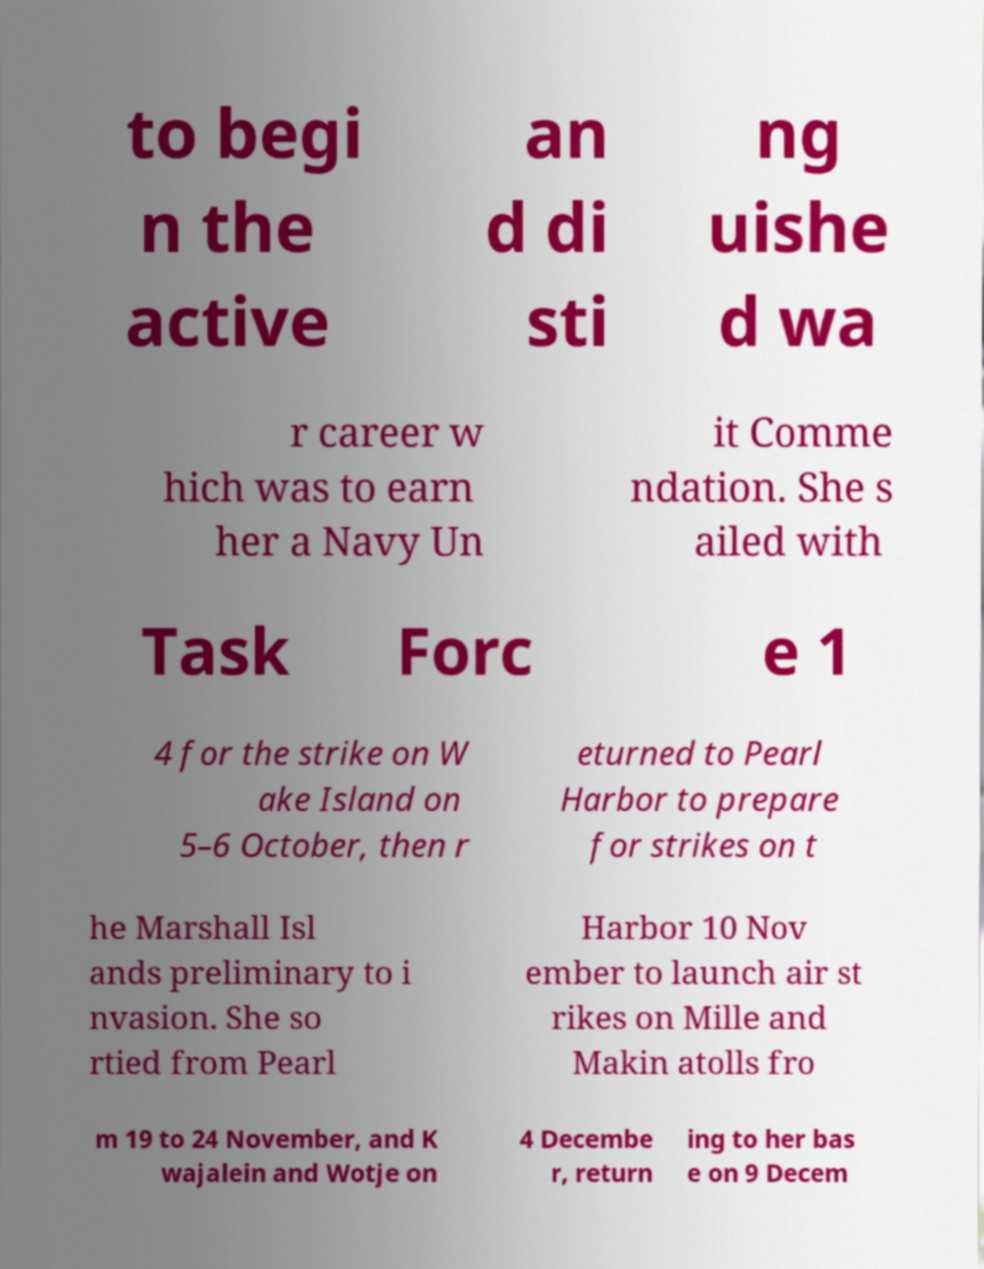I need the written content from this picture converted into text. Can you do that? to begi n the active an d di sti ng uishe d wa r career w hich was to earn her a Navy Un it Comme ndation. She s ailed with Task Forc e 1 4 for the strike on W ake Island on 5–6 October, then r eturned to Pearl Harbor to prepare for strikes on t he Marshall Isl ands preliminary to i nvasion. She so rtied from Pearl Harbor 10 Nov ember to launch air st rikes on Mille and Makin atolls fro m 19 to 24 November, and K wajalein and Wotje on 4 Decembe r, return ing to her bas e on 9 Decem 